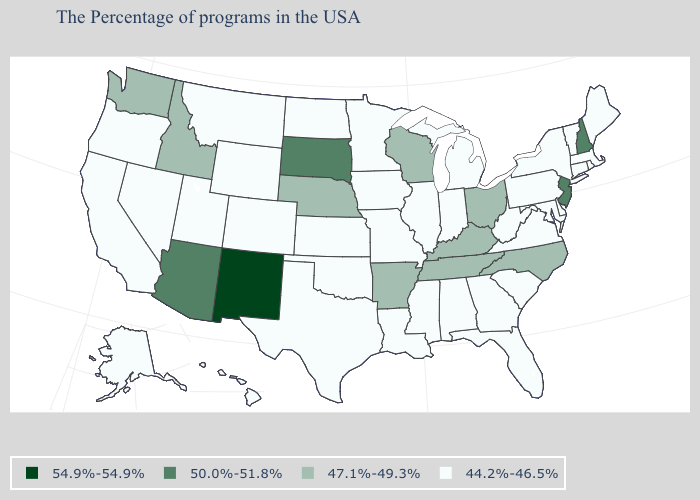What is the value of Colorado?
Quick response, please. 44.2%-46.5%. What is the highest value in the USA?
Concise answer only. 54.9%-54.9%. Name the states that have a value in the range 54.9%-54.9%?
Short answer required. New Mexico. What is the highest value in the West ?
Answer briefly. 54.9%-54.9%. What is the value of Maryland?
Concise answer only. 44.2%-46.5%. Name the states that have a value in the range 54.9%-54.9%?
Quick response, please. New Mexico. What is the lowest value in states that border Vermont?
Keep it brief. 44.2%-46.5%. Does the map have missing data?
Keep it brief. No. What is the highest value in the USA?
Concise answer only. 54.9%-54.9%. Among the states that border Nevada , does Oregon have the highest value?
Short answer required. No. Does Oklahoma have the highest value in the South?
Quick response, please. No. What is the highest value in the Northeast ?
Write a very short answer. 50.0%-51.8%. What is the value of California?
Quick response, please. 44.2%-46.5%. Name the states that have a value in the range 44.2%-46.5%?
Quick response, please. Maine, Massachusetts, Rhode Island, Vermont, Connecticut, New York, Delaware, Maryland, Pennsylvania, Virginia, South Carolina, West Virginia, Florida, Georgia, Michigan, Indiana, Alabama, Illinois, Mississippi, Louisiana, Missouri, Minnesota, Iowa, Kansas, Oklahoma, Texas, North Dakota, Wyoming, Colorado, Utah, Montana, Nevada, California, Oregon, Alaska, Hawaii. Name the states that have a value in the range 50.0%-51.8%?
Answer briefly. New Hampshire, New Jersey, South Dakota, Arizona. 